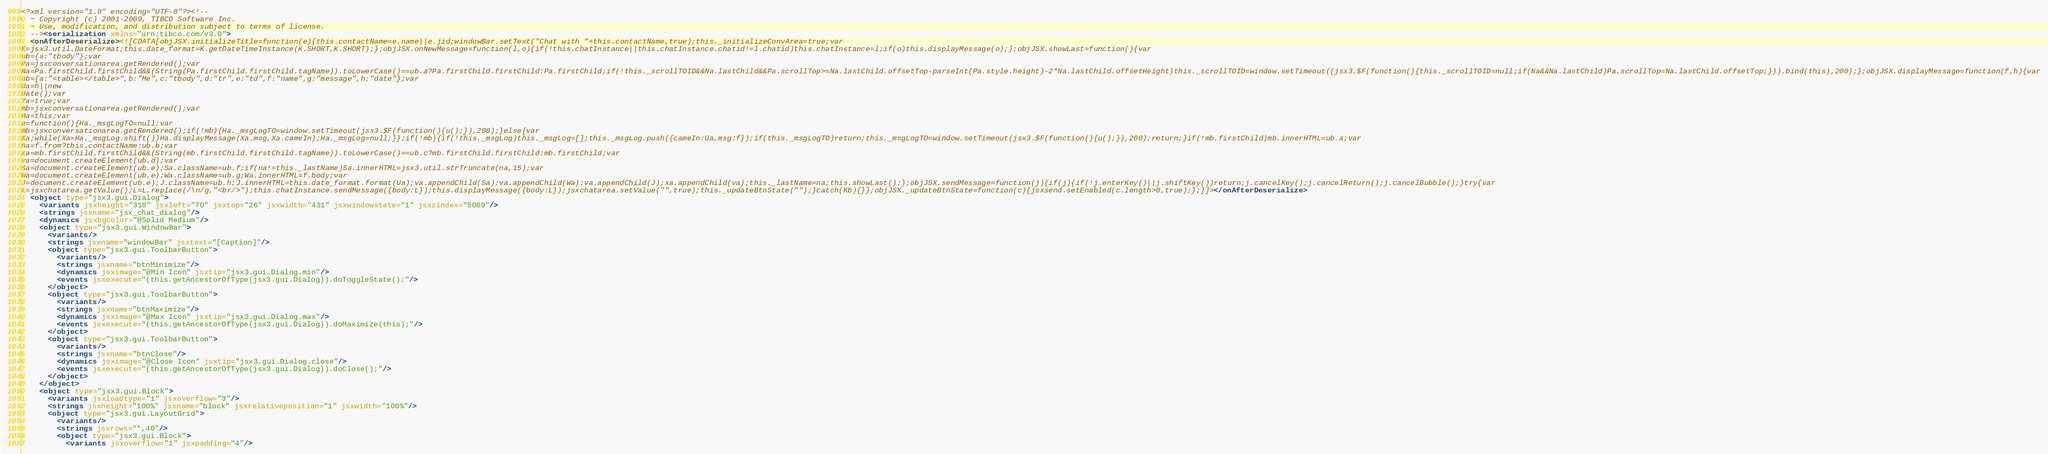<code> <loc_0><loc_0><loc_500><loc_500><_XML_><?xml version="1.0" encoding="UTF-8"?><!--
  ~ Copyright (c) 2001-2009, TIBCO Software Inc.
  ~ Use, modification, and distribution subject to terms of license.
  --><serialization xmlns="urn:tibco.com/v3.0">
  <onAfterDeserialize><![CDATA[objJSX.initializeTitle=function(e){this.contactName=e.name||e.jid;windowBar.setText("Chat with "+this.contactName,true);this._initializeConvArea=true;var
K=jsx3.util.DateFormat;this.date_format=K.getDateTimeInstance(K.SHORT,K.SHORT);};objJSX.onNewMessage=function(l,o){if(!this.chatInstance||this.chatInstance.chatid!=l.chatid)this.chatInstance=l;if(o)this.displayMessage(o);};objJSX.showLast=function(){var
ub={a:"tbody"};var
Pa=jsxconversationarea.getRendered();var
Na=Pa.firstChild.firstChild&&(String(Pa.firstChild.firstChild.tagName)).toLowerCase()==ub.a?Pa.firstChild.firstChild:Pa.firstChild;if(!this._scrollTOID&&Na.lastChild&&Pa.scrollTop>=Na.lastChild.offsetTop-parseInt(Pa.style.height)-2*Na.lastChild.offsetHeight)this._scrollTOID=window.setTimeout((jsx3.$F(function(){this._scrollTOID=null;if(Na&&Na.lastChild)Pa.scrollTop=Na.lastChild.offsetTop;})).bind(this),200);};objJSX.displayMessage=function(f,h){var
ub={a:"<table></table>",b:"Me",c:"tbody",d:"tr",e:"td",f:"name",g:"message",h:"date"};var
Ua=h||new
Date();var
Ya=true;var
mb=jsxconversationarea.getRendered();var
Ha=this;var
u=function(){Ha._msgLogTO=null;var
mb=jsxconversationarea.getRendered();if(!mb){Ha._msgLogTO=window.setTimeout(jsx3.$F(function(){u();}),200);}else{var
Xa;while(Xa=Ha._msgLog.shift())Ha.displayMessage(Xa.msg,Xa.cameIn);Ha._msgLog=null;}};if(!mb){if(!this._msgLog)this._msgLog=[];this._msgLog.push({cameIn:Ua,msg:f});if(this._msgLogTO)return;this._msgLogTO=window.setTimeout(jsx3.$F(function(){u();}),200);return;}if(!mb.firstChild)mb.innerHTML=ub.a;var
na=f.from?this.contactName:ub.b;var
xa=mb.firstChild.firstChild&&(String(mb.firstChild.firstChild.tagName)).toLowerCase()==ub.c?mb.firstChild.firstChild:mb.firstChild;var
va=document.createElement(ub.d);var
Sa=document.createElement(ub.e);Sa.className=ub.f;if(na!=this._lastName)Sa.innerHTML=jsx3.util.strTruncate(na,15);var
Wa=document.createElement(ub.e);Wa.className=ub.g;Wa.innerHTML=f.body;var
J=document.createElement(ub.e);J.className=ub.h;J.innerHTML=this.date_format.format(Ua);va.appendChild(Sa);va.appendChild(Wa);va.appendChild(J);xa.appendChild(va);this._lastName=na;this.showLast();};objJSX.sendMessage=function(j){if(j){if(!j.enterKey()||j.shiftKey())return;j.cancelKey();j.cancelReturn();j.cancelBubble();}try{var
L=jsxchatarea.getValue();L=L.replace(/\n/g,"<br/>");this.chatInstance.sendMessage({body:L});this.displayMessage({body:L});jsxchatarea.setValue("",true);this._updateBtnState("");}catch(Kb){}};objJSX._updateBtnState=function(c){jsxsend.setEnabled(c.length>0,true);};]]></onAfterDeserialize>
  <object type="jsx3.gui.Dialog">
    <variants jsxheight="318" jsxleft="70" jsxtop="26" jsxwidth="431" jsxwindowstate="1" jsxzindex="5009"/>
    <strings jsxname="jsx_chat_dialog"/>
    <dynamics jsxbgcolor="@Solid Medium"/>
    <object type="jsx3.gui.WindowBar">
      <variants/>
      <strings jsxname="windowBar" jsxtext="[Caption]"/>
      <object type="jsx3.gui.ToolbarButton">
        <variants/>
        <strings jsxname="btnMinimize"/>
        <dynamics jsximage="@Min Icon" jsxtip="jsx3.gui.Dialog.min"/>
        <events jsxexecute="(this.getAncestorOfType(jsx3.gui.Dialog)).doToggleState();"/>
      </object>
      <object type="jsx3.gui.ToolbarButton">
        <variants/>
        <strings jsxname="btnMaximize"/>
        <dynamics jsximage="@Max Icon" jsxtip="jsx3.gui.Dialog.max"/>
        <events jsxexecute="(this.getAncestorOfType(jsx3.gui.Dialog)).doMaximize(this);"/>
      </object>
      <object type="jsx3.gui.ToolbarButton">
        <variants/>
        <strings jsxname="btnClose"/>
        <dynamics jsximage="@Close Icon" jsxtip="jsx3.gui.Dialog.close"/>
        <events jsxexecute="(this.getAncestorOfType(jsx3.gui.Dialog)).doClose();"/>
      </object>
    </object>
    <object type="jsx3.gui.Block">
      <variants jsxloadtype="1" jsxoverflow="3"/>
      <strings jsxheight="100%" jsxname="block" jsxrelativeposition="1" jsxwidth="100%"/>
      <object type="jsx3.gui.LayoutGrid">
        <variants/>
        <strings jsxrows="*,40"/>
        <object type="jsx3.gui.Block">
          <variants jsxoverflow="1" jsxpadding="4"/></code> 